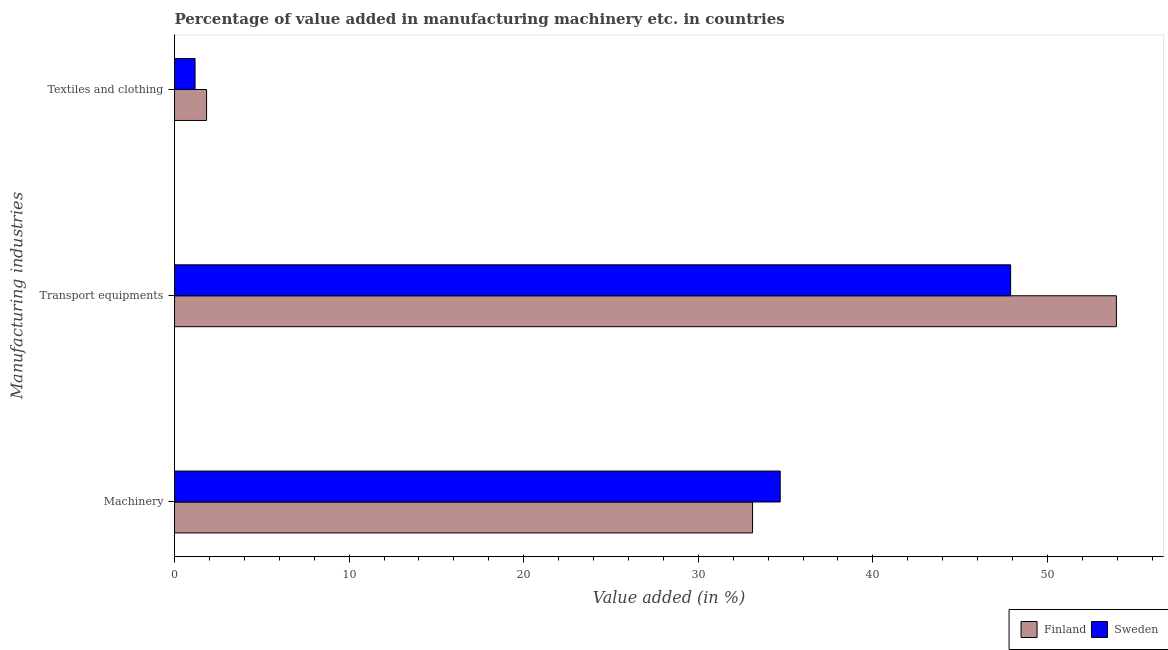Are the number of bars per tick equal to the number of legend labels?
Your answer should be compact. Yes. How many bars are there on the 1st tick from the top?
Your answer should be very brief. 2. How many bars are there on the 2nd tick from the bottom?
Offer a very short reply. 2. What is the label of the 1st group of bars from the top?
Your answer should be compact. Textiles and clothing. What is the value added in manufacturing transport equipments in Sweden?
Offer a very short reply. 47.89. Across all countries, what is the maximum value added in manufacturing transport equipments?
Your response must be concise. 53.95. Across all countries, what is the minimum value added in manufacturing machinery?
Offer a very short reply. 33.11. In which country was the value added in manufacturing transport equipments maximum?
Offer a very short reply. Finland. In which country was the value added in manufacturing textile and clothing minimum?
Your answer should be compact. Sweden. What is the total value added in manufacturing transport equipments in the graph?
Offer a very short reply. 101.84. What is the difference between the value added in manufacturing machinery in Finland and that in Sweden?
Your answer should be very brief. -1.58. What is the difference between the value added in manufacturing transport equipments in Finland and the value added in manufacturing machinery in Sweden?
Your response must be concise. 19.26. What is the average value added in manufacturing transport equipments per country?
Keep it short and to the point. 50.92. What is the difference between the value added in manufacturing transport equipments and value added in manufacturing textile and clothing in Finland?
Keep it short and to the point. 52.11. What is the ratio of the value added in manufacturing machinery in Sweden to that in Finland?
Offer a terse response. 1.05. Is the value added in manufacturing textile and clothing in Sweden less than that in Finland?
Make the answer very short. Yes. Is the difference between the value added in manufacturing textile and clothing in Sweden and Finland greater than the difference between the value added in manufacturing machinery in Sweden and Finland?
Keep it short and to the point. No. What is the difference between the highest and the second highest value added in manufacturing textile and clothing?
Provide a succinct answer. 0.66. What is the difference between the highest and the lowest value added in manufacturing textile and clothing?
Make the answer very short. 0.66. In how many countries, is the value added in manufacturing transport equipments greater than the average value added in manufacturing transport equipments taken over all countries?
Provide a short and direct response. 1. Is the sum of the value added in manufacturing textile and clothing in Sweden and Finland greater than the maximum value added in manufacturing transport equipments across all countries?
Your response must be concise. No. What does the 1st bar from the bottom in Textiles and clothing represents?
Your answer should be compact. Finland. Are all the bars in the graph horizontal?
Provide a short and direct response. Yes. Are the values on the major ticks of X-axis written in scientific E-notation?
Give a very brief answer. No. How many legend labels are there?
Give a very brief answer. 2. What is the title of the graph?
Offer a very short reply. Percentage of value added in manufacturing machinery etc. in countries. What is the label or title of the X-axis?
Provide a short and direct response. Value added (in %). What is the label or title of the Y-axis?
Keep it short and to the point. Manufacturing industries. What is the Value added (in %) of Finland in Machinery?
Make the answer very short. 33.11. What is the Value added (in %) of Sweden in Machinery?
Ensure brevity in your answer.  34.69. What is the Value added (in %) of Finland in Transport equipments?
Make the answer very short. 53.95. What is the Value added (in %) of Sweden in Transport equipments?
Provide a short and direct response. 47.89. What is the Value added (in %) of Finland in Textiles and clothing?
Offer a very short reply. 1.83. What is the Value added (in %) of Sweden in Textiles and clothing?
Give a very brief answer. 1.17. Across all Manufacturing industries, what is the maximum Value added (in %) of Finland?
Give a very brief answer. 53.95. Across all Manufacturing industries, what is the maximum Value added (in %) of Sweden?
Give a very brief answer. 47.89. Across all Manufacturing industries, what is the minimum Value added (in %) in Finland?
Ensure brevity in your answer.  1.83. Across all Manufacturing industries, what is the minimum Value added (in %) of Sweden?
Provide a succinct answer. 1.17. What is the total Value added (in %) in Finland in the graph?
Make the answer very short. 88.89. What is the total Value added (in %) of Sweden in the graph?
Your answer should be very brief. 83.76. What is the difference between the Value added (in %) of Finland in Machinery and that in Transport equipments?
Ensure brevity in your answer.  -20.84. What is the difference between the Value added (in %) in Sweden in Machinery and that in Transport equipments?
Your answer should be very brief. -13.2. What is the difference between the Value added (in %) of Finland in Machinery and that in Textiles and clothing?
Ensure brevity in your answer.  31.27. What is the difference between the Value added (in %) in Sweden in Machinery and that in Textiles and clothing?
Make the answer very short. 33.52. What is the difference between the Value added (in %) of Finland in Transport equipments and that in Textiles and clothing?
Offer a very short reply. 52.11. What is the difference between the Value added (in %) of Sweden in Transport equipments and that in Textiles and clothing?
Make the answer very short. 46.72. What is the difference between the Value added (in %) of Finland in Machinery and the Value added (in %) of Sweden in Transport equipments?
Your answer should be very brief. -14.78. What is the difference between the Value added (in %) in Finland in Machinery and the Value added (in %) in Sweden in Textiles and clothing?
Keep it short and to the point. 31.93. What is the difference between the Value added (in %) in Finland in Transport equipments and the Value added (in %) in Sweden in Textiles and clothing?
Your answer should be compact. 52.77. What is the average Value added (in %) of Finland per Manufacturing industries?
Provide a short and direct response. 29.63. What is the average Value added (in %) of Sweden per Manufacturing industries?
Keep it short and to the point. 27.92. What is the difference between the Value added (in %) of Finland and Value added (in %) of Sweden in Machinery?
Provide a short and direct response. -1.58. What is the difference between the Value added (in %) of Finland and Value added (in %) of Sweden in Transport equipments?
Your answer should be compact. 6.06. What is the difference between the Value added (in %) of Finland and Value added (in %) of Sweden in Textiles and clothing?
Offer a very short reply. 0.66. What is the ratio of the Value added (in %) in Finland in Machinery to that in Transport equipments?
Offer a very short reply. 0.61. What is the ratio of the Value added (in %) in Sweden in Machinery to that in Transport equipments?
Ensure brevity in your answer.  0.72. What is the ratio of the Value added (in %) in Finland in Machinery to that in Textiles and clothing?
Offer a terse response. 18.05. What is the ratio of the Value added (in %) in Sweden in Machinery to that in Textiles and clothing?
Your response must be concise. 29.54. What is the ratio of the Value added (in %) of Finland in Transport equipments to that in Textiles and clothing?
Your answer should be very brief. 29.41. What is the ratio of the Value added (in %) of Sweden in Transport equipments to that in Textiles and clothing?
Offer a very short reply. 40.77. What is the difference between the highest and the second highest Value added (in %) of Finland?
Offer a terse response. 20.84. What is the difference between the highest and the second highest Value added (in %) of Sweden?
Your answer should be very brief. 13.2. What is the difference between the highest and the lowest Value added (in %) of Finland?
Provide a short and direct response. 52.11. What is the difference between the highest and the lowest Value added (in %) in Sweden?
Offer a terse response. 46.72. 